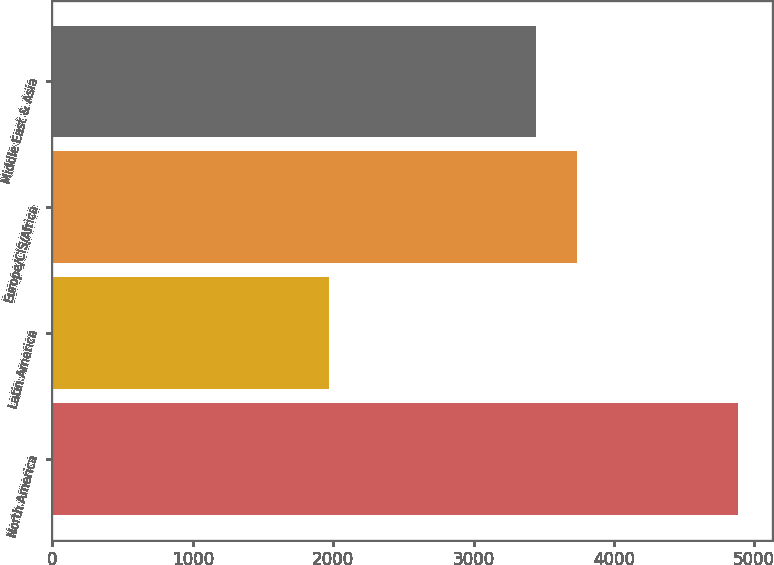Convert chart. <chart><loc_0><loc_0><loc_500><loc_500><bar_chart><fcel>North America<fcel>Latin America<fcel>Europe/CIS/Africa<fcel>Middle East & Asia<nl><fcel>4885<fcel>1969<fcel>3737.6<fcel>3446<nl></chart> 